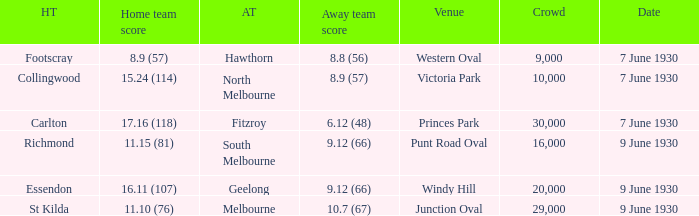What is the average crowd to watch Hawthorn as the away team? 9000.0. 